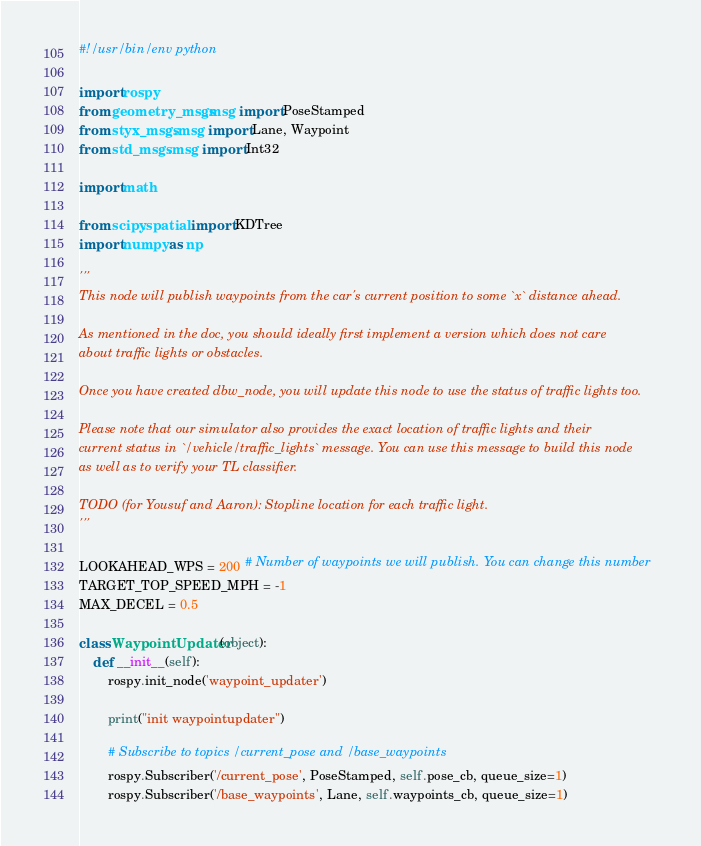<code> <loc_0><loc_0><loc_500><loc_500><_Python_>#!/usr/bin/env python

import rospy
from geometry_msgs.msg import PoseStamped
from styx_msgs.msg import Lane, Waypoint
from std_msgs.msg import Int32

import math

from scipy.spatial import KDTree
import numpy as np

'''
This node will publish waypoints from the car's current position to some `x` distance ahead.

As mentioned in the doc, you should ideally first implement a version which does not care
about traffic lights or obstacles.

Once you have created dbw_node, you will update this node to use the status of traffic lights too.

Please note that our simulator also provides the exact location of traffic lights and their
current status in `/vehicle/traffic_lights` message. You can use this message to build this node
as well as to verify your TL classifier.

TODO (for Yousuf and Aaron): Stopline location for each traffic light.
'''

LOOKAHEAD_WPS = 200 # Number of waypoints we will publish. You can change this number
TARGET_TOP_SPEED_MPH = -1
MAX_DECEL = 0.5

class WaypointUpdater(object):
    def __init__(self):
        rospy.init_node('waypoint_updater')

        print("init waypointupdater")
 
        # Subscribe to topics /current_pose and /base_waypoints
        rospy.Subscriber('/current_pose', PoseStamped, self.pose_cb, queue_size=1)
        rospy.Subscriber('/base_waypoints', Lane, self.waypoints_cb, queue_size=1)
</code> 